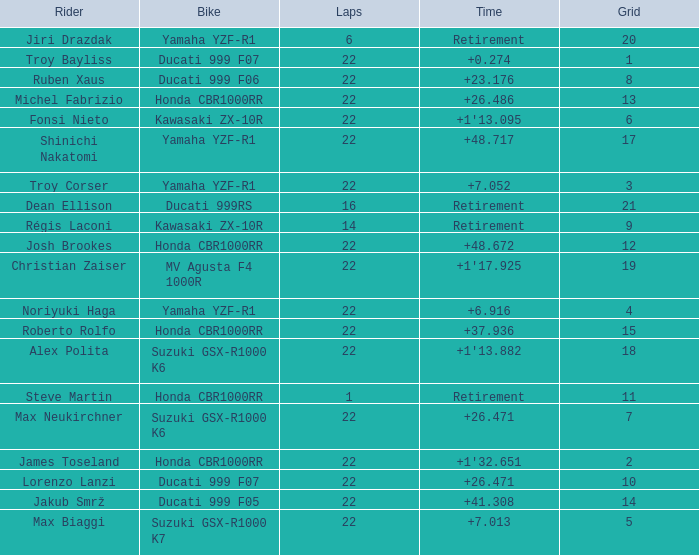When the grid number is 10, what is the total number of laps? 1.0. 